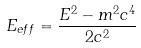Convert formula to latex. <formula><loc_0><loc_0><loc_500><loc_500>E _ { e f f } = \frac { E ^ { 2 } - m ^ { 2 } c ^ { 4 } } { 2 c ^ { 2 } }</formula> 